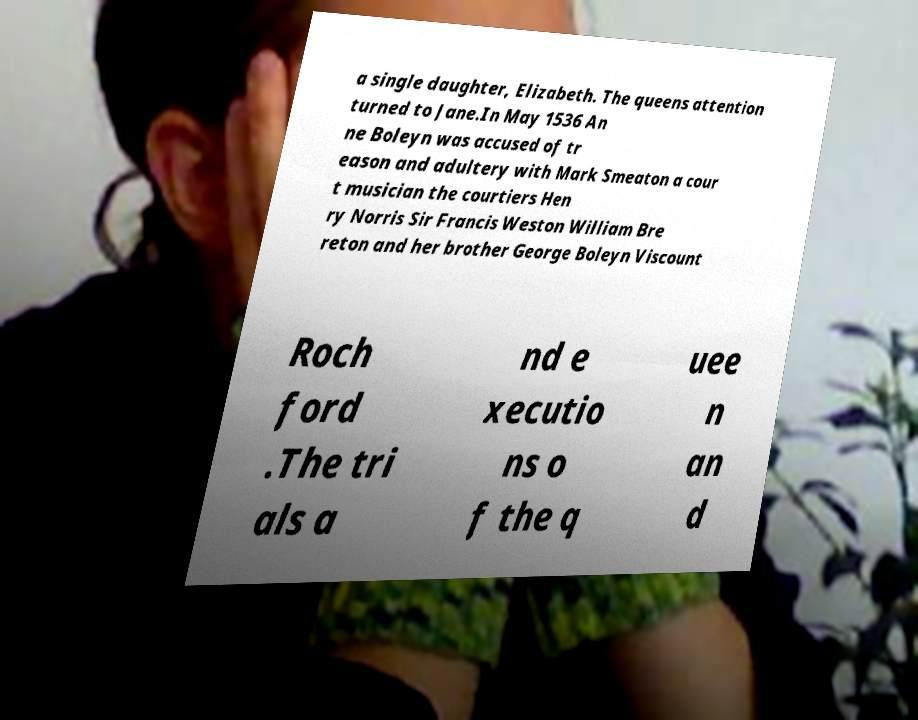Please identify and transcribe the text found in this image. a single daughter, Elizabeth. The queens attention turned to Jane.In May 1536 An ne Boleyn was accused of tr eason and adultery with Mark Smeaton a cour t musician the courtiers Hen ry Norris Sir Francis Weston William Bre reton and her brother George Boleyn Viscount Roch ford .The tri als a nd e xecutio ns o f the q uee n an d 